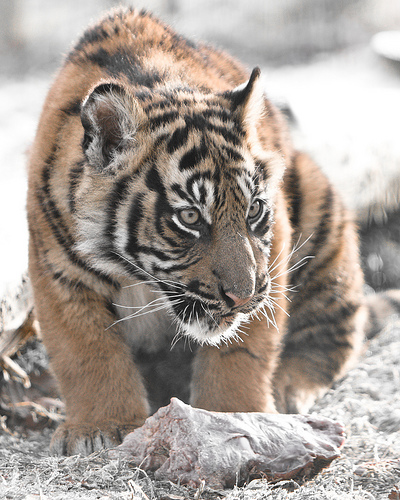<image>
Can you confirm if the tiger is above the ground? No. The tiger is not positioned above the ground. The vertical arrangement shows a different relationship. 